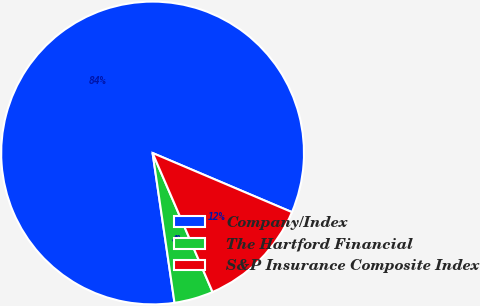Convert chart to OTSL. <chart><loc_0><loc_0><loc_500><loc_500><pie_chart><fcel>Company/Index<fcel>The Hartford Financial<fcel>S&P Insurance Composite Index<nl><fcel>83.7%<fcel>4.17%<fcel>12.13%<nl></chart> 